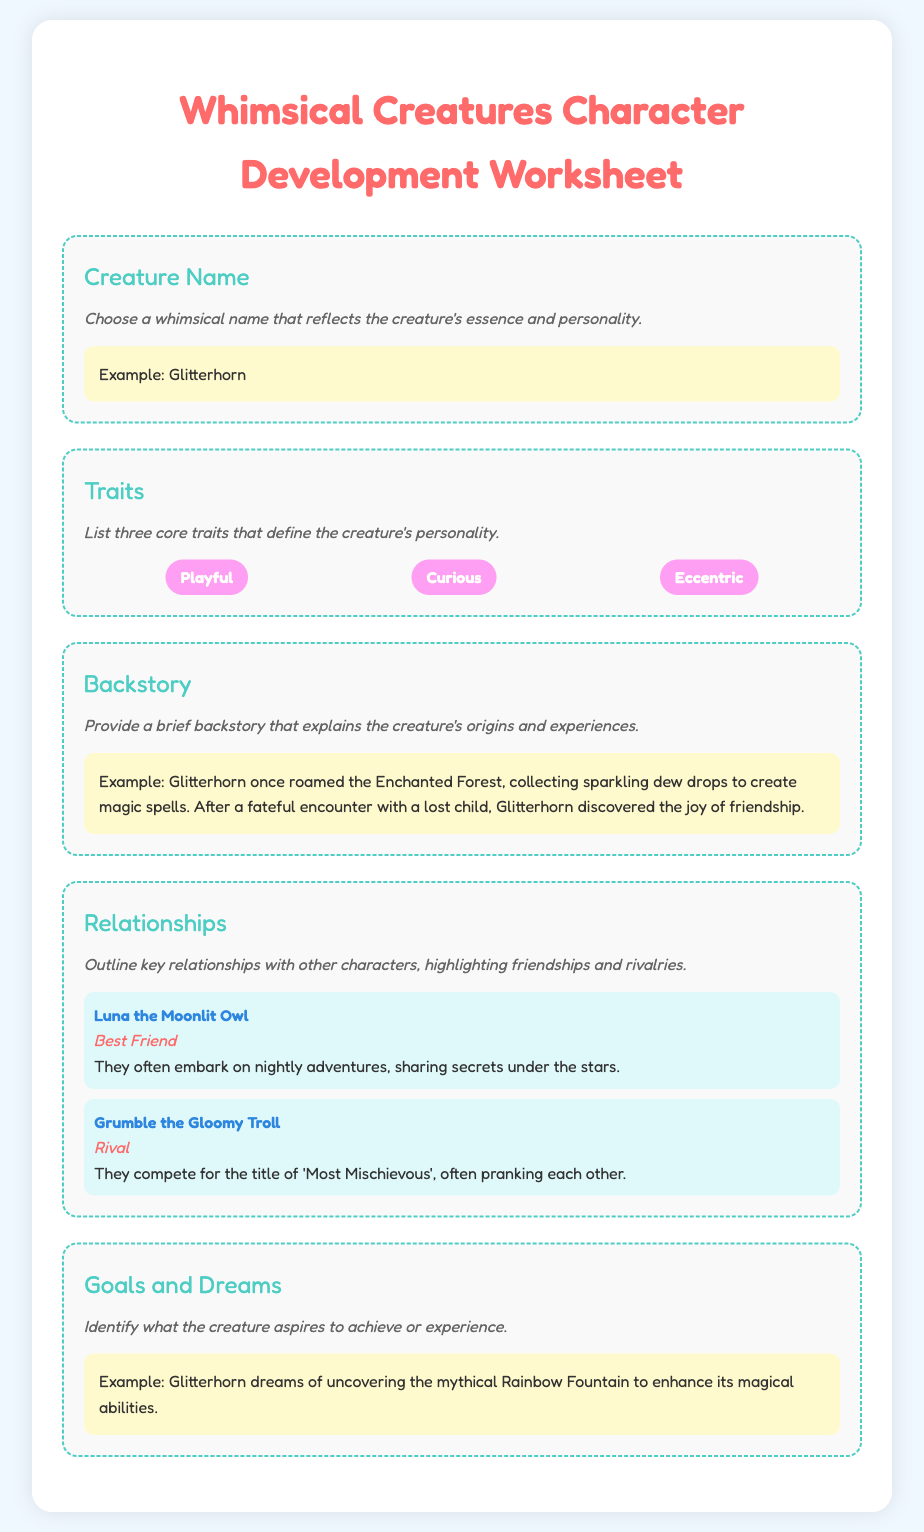What is the title of the worksheet? The title of the worksheet is prominently displayed at the top of the document.
Answer: Whimsical Creatures Character Development Worksheet What are three core traits listed for the creatures? The document specifies three key traits that define the creature's personality.
Answer: Playful, Curious, Eccentric What is an example of a creature name given in the document? An example of a whimsical creature name is provided in the section about naming the character.
Answer: Glitterhorn Who is Glitterhorn's best friend? The relationships section identifies Glitterhorn's key friendships and rivalries.
Answer: Luna the Moonlit Owl What type of relationship does Glitterhorn have with Grumble? The document outlines different types of relationships, highlighting friendships and rivalries.
Answer: Rival What is one of Glitterhorn's dreams? The goals and dreams section describes what the creature aspires to achieve.
Answer: Uncovering the mythical Rainbow Fountain How is the character's backstory described? The backstory section gives an overview of the creature's origins and experiences.
Answer: Brief backstory What color is used for the section titles? The section titles are presented in a specific color that adds to the whimsical aesthetic of the document.
Answer: #4ecdc4 